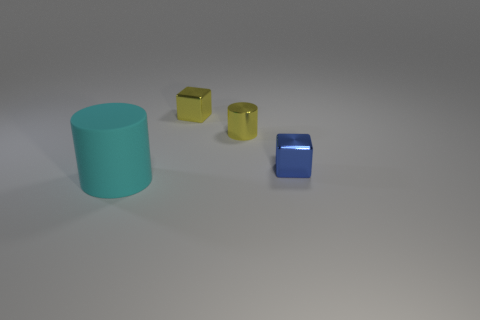Add 1 blue metal objects. How many objects exist? 5 Add 3 big cyan rubber cylinders. How many big cyan rubber cylinders exist? 4 Subtract 0 cyan blocks. How many objects are left? 4 Subtract all brown shiny balls. Subtract all yellow cylinders. How many objects are left? 3 Add 2 yellow metallic blocks. How many yellow metallic blocks are left? 3 